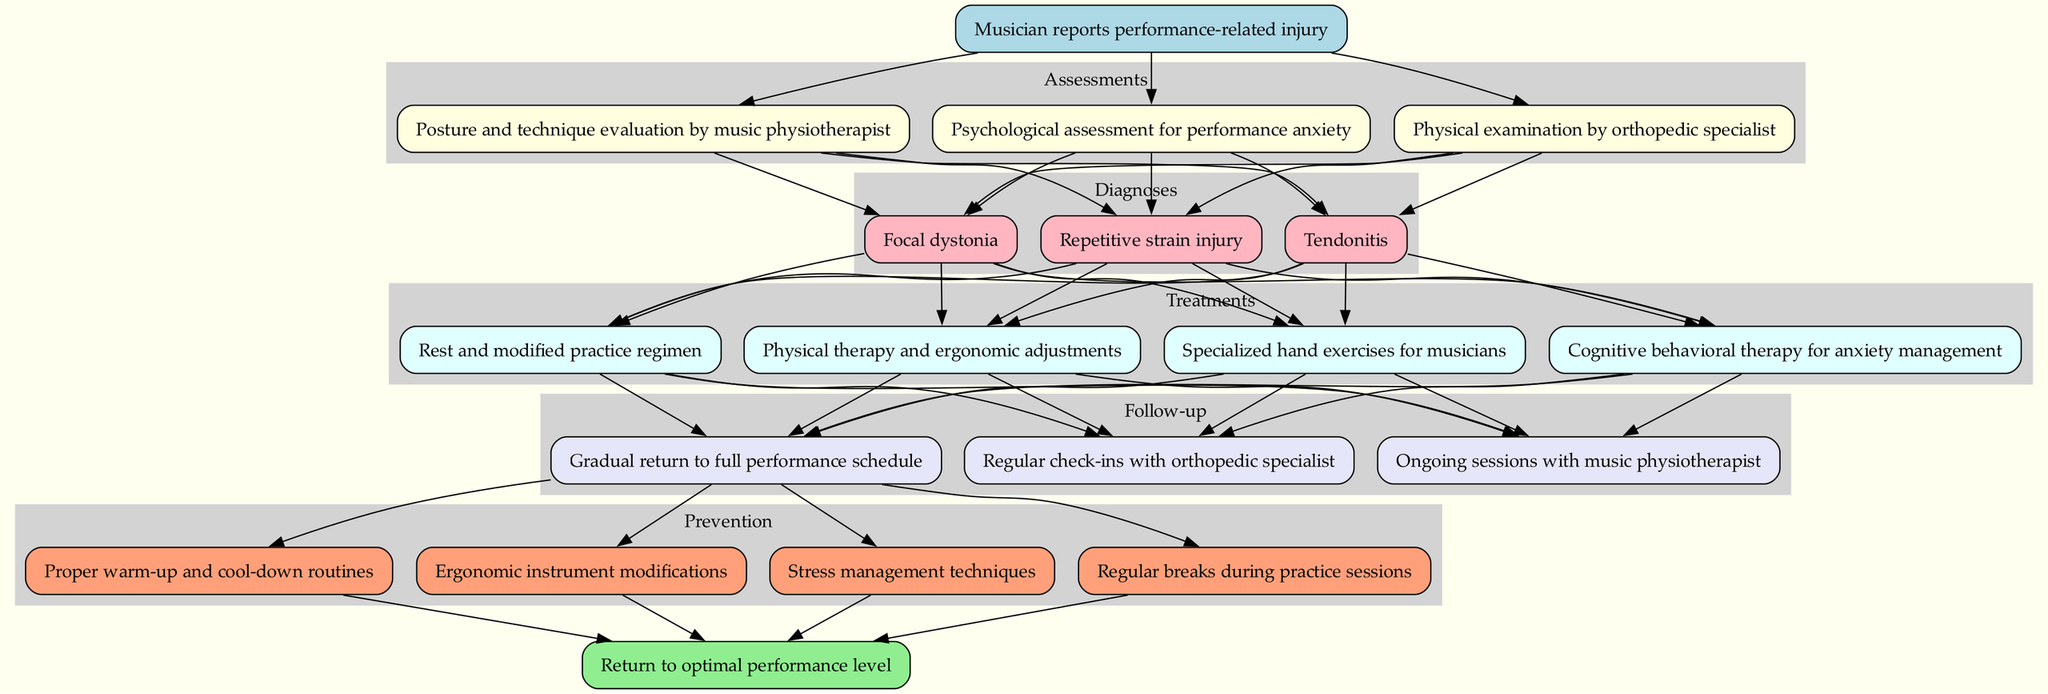What is the first step in the pathway? The first step in the clinical pathway is indicated by the 'start' node, which states that the musician reports a performance-related injury.
Answer: Musician reports performance-related injury How many assessments are listed in the diagram? The diagram includes a cluster labeled 'Assessments', which contains three specific assessments outlined within it.
Answer: 3 Which treatment follows the diagnosis of Tendonitis? The edges from the diagnosis nodes indicate that treatments stem from each diagnosis, and from Tendonitis, one of the treatments could be chosen. The specific options include rest, physical therapy, specialized hand exercises, or cognitive behavioral therapy.
Answer: Physical therapy and ergonomic adjustments What is one prevention strategy after follow-up? The prevention strategies are shown after the follow-up nodes. Each prevention node corresponds to a strategy one can take to avoid future injuries, with the first being proper warm-up and cool-down routines.
Answer: Proper warm-up and cool-down routines How many follow-up options are provided? In the 'Follow-up' section of the diagram, there are three different follow-up strategies listed, indicating the various ways to continue after treatments.
Answer: 3 What is the last node before reaching "Return to optimal performance level"? The final nodes that connect directly to the 'end' node are the prevention strategies, which culminate in the return to optimal performance.
Answer: Any prevention strategy Which assessments are associated with diagnosing Focal dystonia? To diagnose Focal dystonia, the diagram establishes relationships from all assessments, meaning it is influenced by the physical examination, posture evaluation, and psychological assessment.
Answer: All assessments 